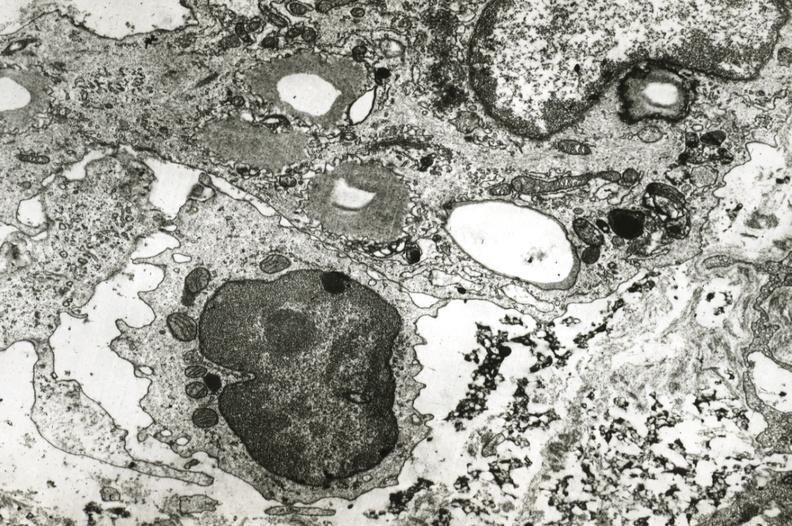what is present?
Answer the question using a single word or phrase. Coronary artery 